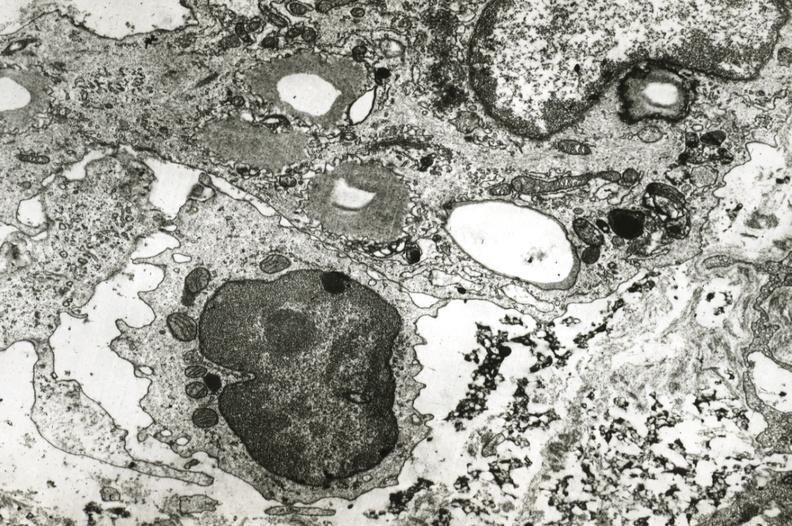what is present?
Answer the question using a single word or phrase. Coronary artery 